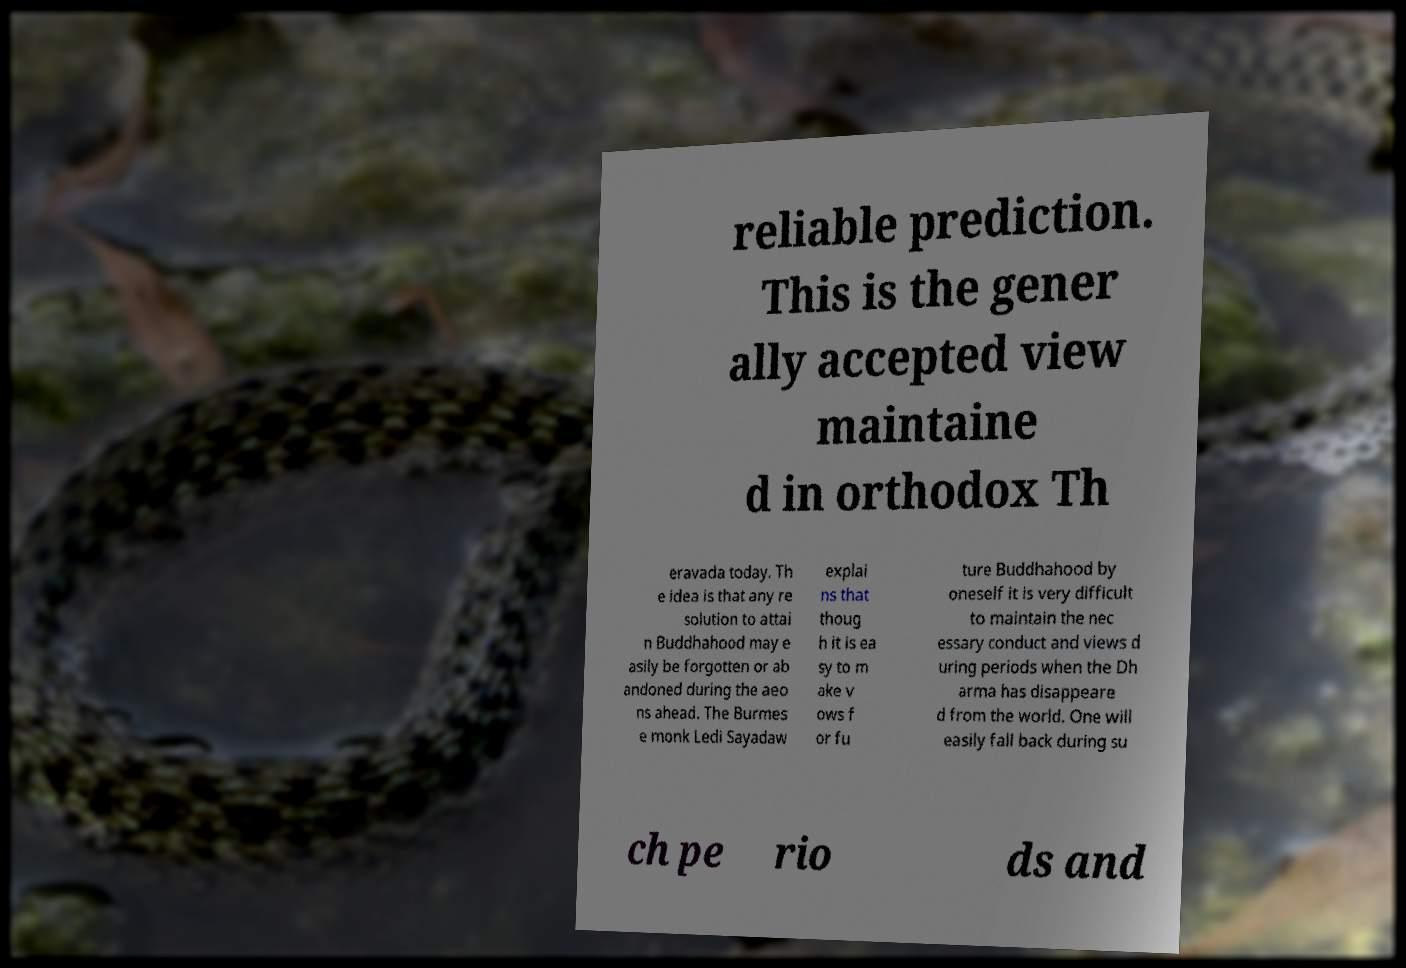Please identify and transcribe the text found in this image. reliable prediction. This is the gener ally accepted view maintaine d in orthodox Th eravada today. Th e idea is that any re solution to attai n Buddhahood may e asily be forgotten or ab andoned during the aeo ns ahead. The Burmes e monk Ledi Sayadaw explai ns that thoug h it is ea sy to m ake v ows f or fu ture Buddhahood by oneself it is very difficult to maintain the nec essary conduct and views d uring periods when the Dh arma has disappeare d from the world. One will easily fall back during su ch pe rio ds and 